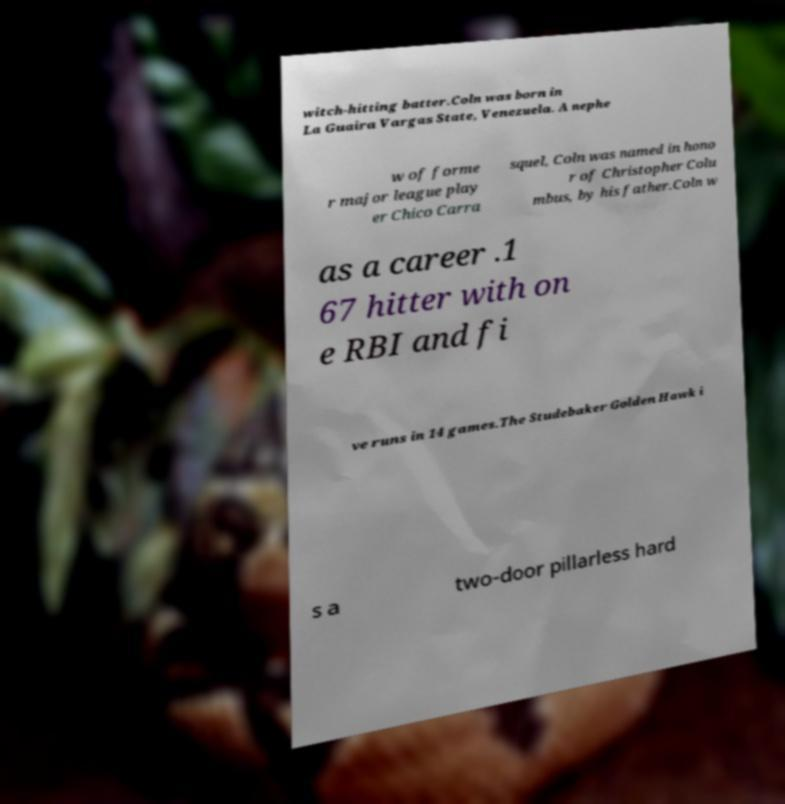What messages or text are displayed in this image? I need them in a readable, typed format. witch-hitting batter.Coln was born in La Guaira Vargas State, Venezuela. A nephe w of forme r major league play er Chico Carra squel, Coln was named in hono r of Christopher Colu mbus, by his father.Coln w as a career .1 67 hitter with on e RBI and fi ve runs in 14 games.The Studebaker Golden Hawk i s a two-door pillarless hard 